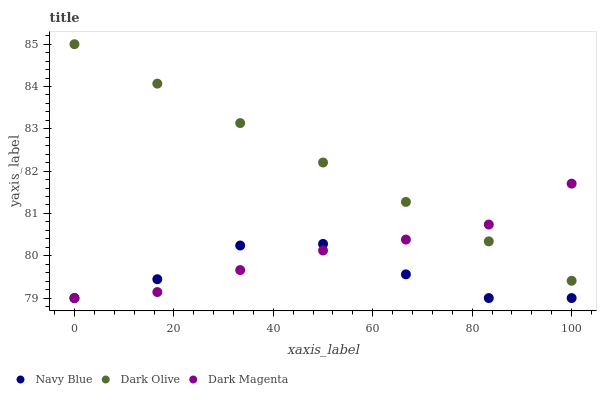Does Navy Blue have the minimum area under the curve?
Answer yes or no. Yes. Does Dark Olive have the maximum area under the curve?
Answer yes or no. Yes. Does Dark Magenta have the minimum area under the curve?
Answer yes or no. No. Does Dark Magenta have the maximum area under the curve?
Answer yes or no. No. Is Dark Olive the smoothest?
Answer yes or no. Yes. Is Navy Blue the roughest?
Answer yes or no. Yes. Is Dark Magenta the smoothest?
Answer yes or no. No. Is Dark Magenta the roughest?
Answer yes or no. No. Does Navy Blue have the lowest value?
Answer yes or no. Yes. Does Dark Olive have the lowest value?
Answer yes or no. No. Does Dark Olive have the highest value?
Answer yes or no. Yes. Does Dark Magenta have the highest value?
Answer yes or no. No. Is Navy Blue less than Dark Olive?
Answer yes or no. Yes. Is Dark Olive greater than Navy Blue?
Answer yes or no. Yes. Does Navy Blue intersect Dark Magenta?
Answer yes or no. Yes. Is Navy Blue less than Dark Magenta?
Answer yes or no. No. Is Navy Blue greater than Dark Magenta?
Answer yes or no. No. Does Navy Blue intersect Dark Olive?
Answer yes or no. No. 